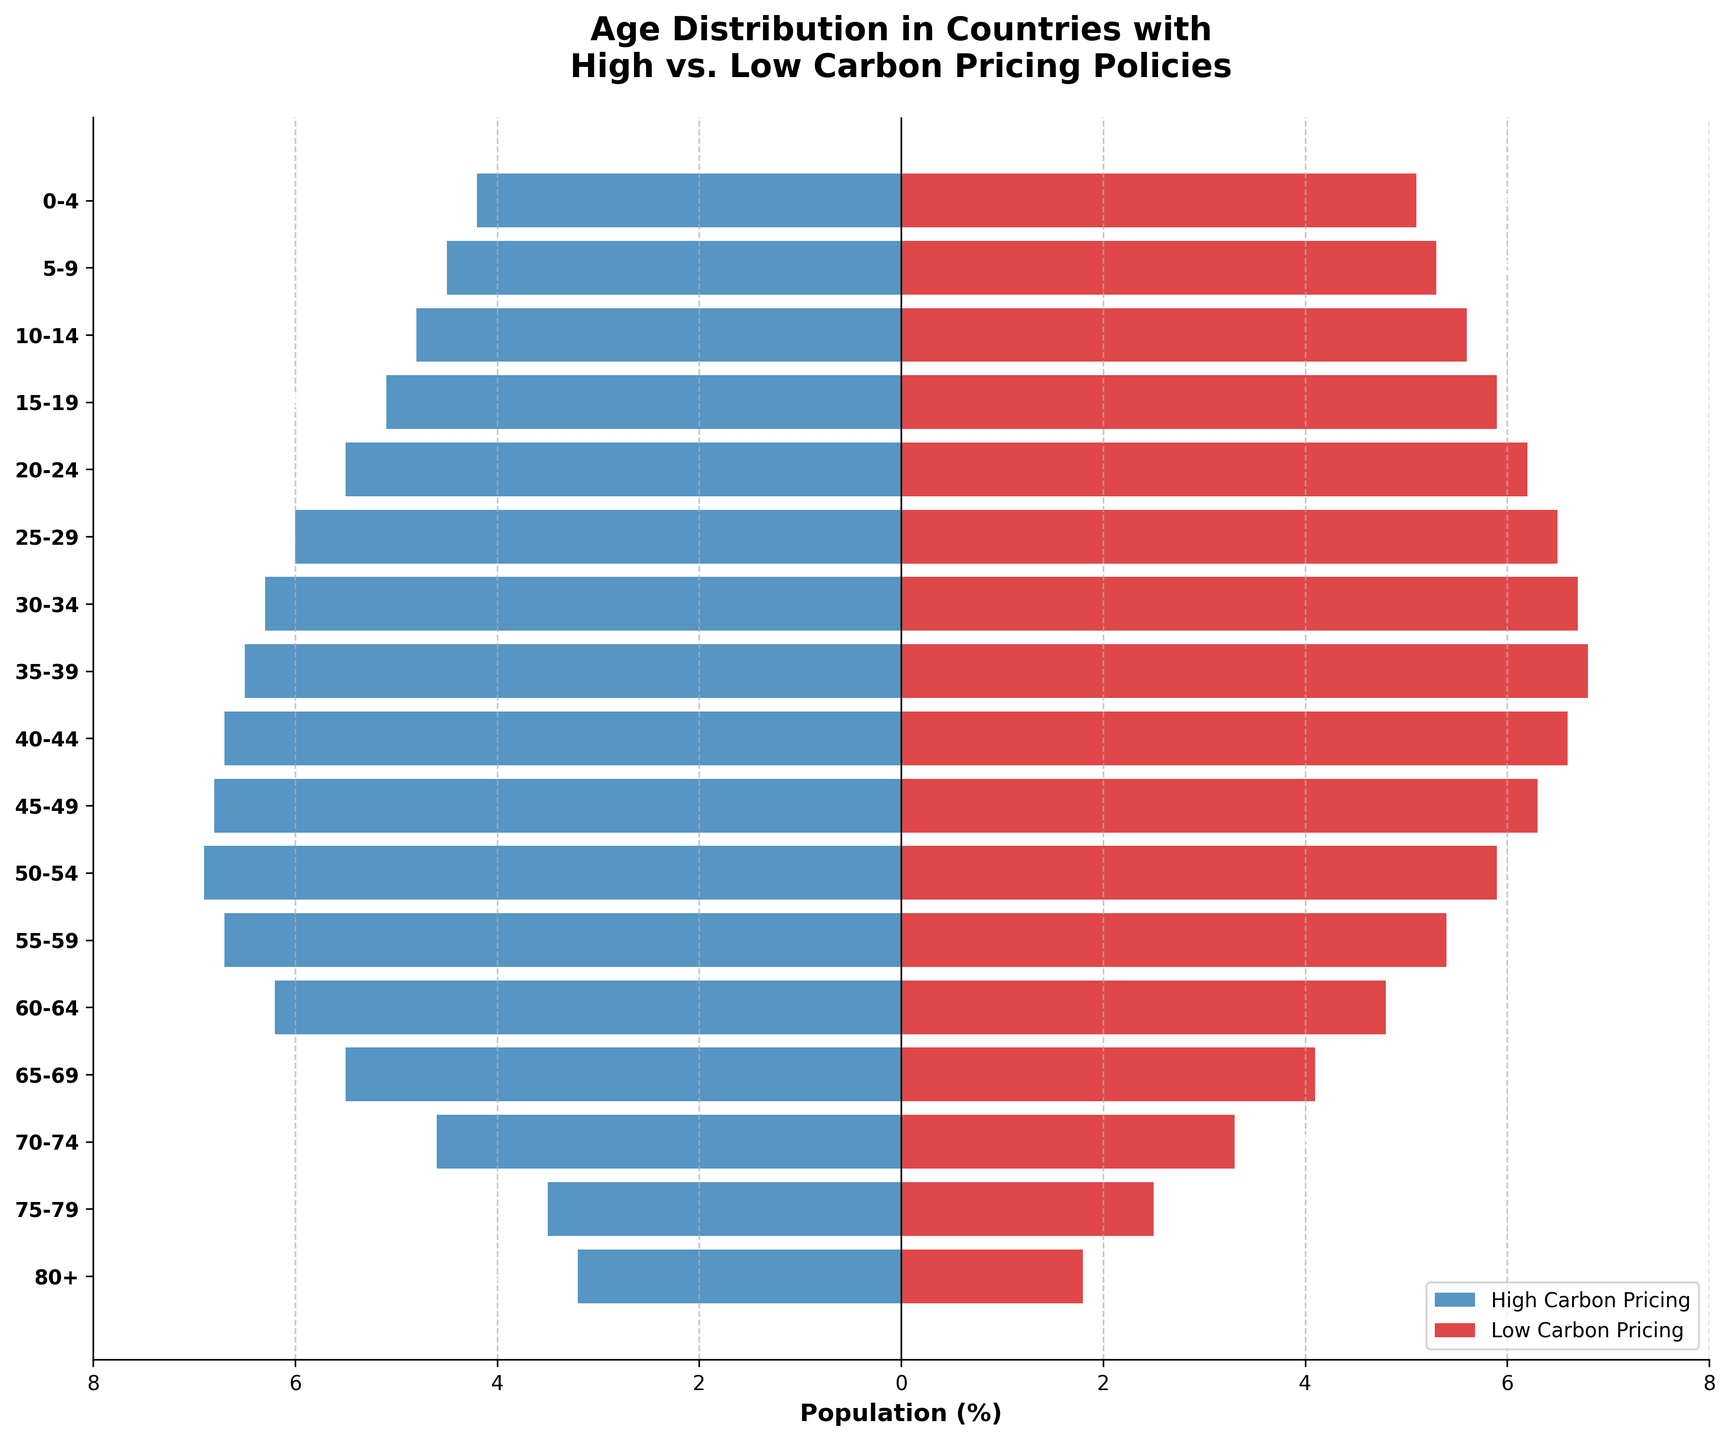what is the title of the figure? The title of the figure is placed prominently at the top and reads "Age Distribution in Countries with High vs. Low Carbon Pricing Policies." This tells us the demographic focus and the comparison framework between two sets of countries differentiated by their carbon pricing policies.
Answer: Age Distribution in Countries with High vs. Low Carbon Pricing Policies What color represents high carbon pricing countries? The color representing high carbon pricing countries is a shade of blue, seen on the left side of the pyramid. Specific elements like these help viewers quickly recognize and differentiate the categories being compared visually.
Answer: Blue Which age group has the highest percentage in low carbon pricing countries? The highest percentage in low carbon pricing countries is seen in the age group 35-39. This is identified by the longest bar on the right side of the population pyramid, specifically for low carbon pricing countries marked in red.
Answer: 35-39 What is the percentage for the age group 25-29 in countries with high carbon pricing? The percentage for the age group 25-29 in high carbon pricing countries is -6.0%. This percentage is visually indicated by the length of the blue bar corresponding to this age group.
Answer: -6.0% Which age group has the narrowest bar in countries with low carbon pricing, and what is it? The narrowest bar among low carbon pricing countries is for the age group 80+. This can be visually confirmed as its bar is very short compared to others, at 1.8%.
Answer: 80+, 1.8% What is the percentage difference between the age group 0-4 in high vs. low carbon pricing countries? In high carbon pricing countries, the percentage for the age group 0-4 is -4.2%, and in low carbon pricing countries, it is 5.1%. The difference is calculated as (5.1 - (-4.2)) = 5.1 + 4.2 = 9.3%.
Answer: 9.3% How does the population distribution trend differ between high and low carbon pricing countries as age increases? As age increases, the population in high carbon pricing countries represented by blue bars decreases more gradually than the rapid decline seen in low carbon pricing countries, represented by red bars, after the 55-59 age group. This suggests a relatively older population in high carbon pricing countries.
Answer: Older population in high carbon pricing countries Which side of the figure generally has more younger age groups (0-19)? The younger age groups (0-19) are generally more represented on the right side, which stands for low carbon pricing countries, as indicated by longer bars in that region.
Answer: Right side (Low carbon pricing countries) Compare the population percentage of 50-54 age group between high and low carbon pricing countries. For the age group 50-54, high carbon pricing countries have a population percentage of -6.9%, while low carbon pricing countries have a percentage of 5.9%. Directly comparing these values: -6.9 is closer to zero on the negative side, and 5.9 is a prominent positive bar on the right side.
Answer: -6.9% (High), 5.9% (Low) Is the population more evenly distributed across age groups in high carbon pricing countries or low carbon pricing countries? The population in high carbon pricing countries (blue bars) shows a more uniform decrease across age groups without sudden drops, whereas in low carbon pricing countries (red bars), there are more significant drops and peaks. This indicates that high carbon pricing countries have a more even population distribution across age groups.
Answer: High carbon pricing countries 